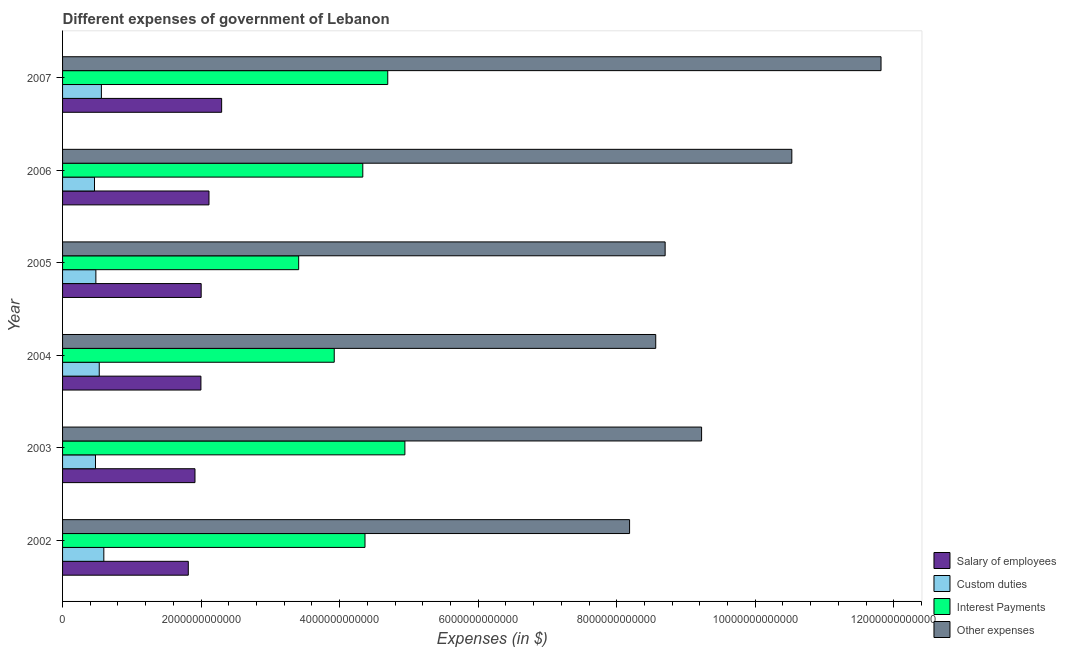How many different coloured bars are there?
Offer a terse response. 4. How many groups of bars are there?
Keep it short and to the point. 6. Are the number of bars on each tick of the Y-axis equal?
Your answer should be very brief. Yes. What is the amount spent on interest payments in 2006?
Your answer should be compact. 4.33e+12. Across all years, what is the maximum amount spent on salary of employees?
Make the answer very short. 2.30e+12. Across all years, what is the minimum amount spent on custom duties?
Your response must be concise. 4.61e+11. In which year was the amount spent on salary of employees maximum?
Keep it short and to the point. 2007. In which year was the amount spent on other expenses minimum?
Provide a succinct answer. 2002. What is the total amount spent on other expenses in the graph?
Provide a short and direct response. 5.70e+13. What is the difference between the amount spent on custom duties in 2002 and that in 2007?
Offer a very short reply. 3.51e+1. What is the difference between the amount spent on custom duties in 2004 and the amount spent on salary of employees in 2006?
Your answer should be very brief. -1.58e+12. What is the average amount spent on salary of employees per year?
Keep it short and to the point. 2.02e+12. In the year 2007, what is the difference between the amount spent on salary of employees and amount spent on interest payments?
Make the answer very short. -2.40e+12. What is the ratio of the amount spent on interest payments in 2004 to that in 2007?
Provide a succinct answer. 0.83. Is the difference between the amount spent on other expenses in 2003 and 2004 greater than the difference between the amount spent on custom duties in 2003 and 2004?
Your answer should be compact. Yes. What is the difference between the highest and the second highest amount spent on interest payments?
Make the answer very short. 2.47e+11. What is the difference between the highest and the lowest amount spent on custom duties?
Offer a terse response. 1.34e+11. In how many years, is the amount spent on interest payments greater than the average amount spent on interest payments taken over all years?
Your response must be concise. 4. Is the sum of the amount spent on salary of employees in 2003 and 2005 greater than the maximum amount spent on interest payments across all years?
Your answer should be compact. No. What does the 4th bar from the top in 2002 represents?
Provide a short and direct response. Salary of employees. What does the 3rd bar from the bottom in 2004 represents?
Offer a terse response. Interest Payments. Is it the case that in every year, the sum of the amount spent on salary of employees and amount spent on custom duties is greater than the amount spent on interest payments?
Keep it short and to the point. No. How many bars are there?
Your response must be concise. 24. How many years are there in the graph?
Keep it short and to the point. 6. What is the difference between two consecutive major ticks on the X-axis?
Provide a short and direct response. 2.00e+12. Are the values on the major ticks of X-axis written in scientific E-notation?
Your answer should be very brief. No. Does the graph contain any zero values?
Give a very brief answer. No. Does the graph contain grids?
Ensure brevity in your answer.  No. Where does the legend appear in the graph?
Your response must be concise. Bottom right. How are the legend labels stacked?
Keep it short and to the point. Vertical. What is the title of the graph?
Provide a succinct answer. Different expenses of government of Lebanon. What is the label or title of the X-axis?
Give a very brief answer. Expenses (in $). What is the label or title of the Y-axis?
Provide a short and direct response. Year. What is the Expenses (in $) of Salary of employees in 2002?
Your response must be concise. 1.82e+12. What is the Expenses (in $) of Custom duties in 2002?
Offer a terse response. 5.96e+11. What is the Expenses (in $) of Interest Payments in 2002?
Make the answer very short. 4.37e+12. What is the Expenses (in $) of Other expenses in 2002?
Provide a short and direct response. 8.19e+12. What is the Expenses (in $) of Salary of employees in 2003?
Give a very brief answer. 1.91e+12. What is the Expenses (in $) of Custom duties in 2003?
Give a very brief answer. 4.75e+11. What is the Expenses (in $) of Interest Payments in 2003?
Your response must be concise. 4.94e+12. What is the Expenses (in $) of Other expenses in 2003?
Give a very brief answer. 9.23e+12. What is the Expenses (in $) in Salary of employees in 2004?
Ensure brevity in your answer.  2.00e+12. What is the Expenses (in $) of Custom duties in 2004?
Offer a very short reply. 5.30e+11. What is the Expenses (in $) in Interest Payments in 2004?
Provide a short and direct response. 3.92e+12. What is the Expenses (in $) of Other expenses in 2004?
Your response must be concise. 8.56e+12. What is the Expenses (in $) of Salary of employees in 2005?
Offer a very short reply. 2.00e+12. What is the Expenses (in $) in Custom duties in 2005?
Provide a short and direct response. 4.81e+11. What is the Expenses (in $) in Interest Payments in 2005?
Ensure brevity in your answer.  3.41e+12. What is the Expenses (in $) of Other expenses in 2005?
Offer a terse response. 8.70e+12. What is the Expenses (in $) of Salary of employees in 2006?
Provide a succinct answer. 2.11e+12. What is the Expenses (in $) of Custom duties in 2006?
Offer a terse response. 4.61e+11. What is the Expenses (in $) of Interest Payments in 2006?
Keep it short and to the point. 4.33e+12. What is the Expenses (in $) in Other expenses in 2006?
Your answer should be very brief. 1.05e+13. What is the Expenses (in $) in Salary of employees in 2007?
Your answer should be compact. 2.30e+12. What is the Expenses (in $) of Custom duties in 2007?
Give a very brief answer. 5.61e+11. What is the Expenses (in $) in Interest Payments in 2007?
Your answer should be very brief. 4.69e+12. What is the Expenses (in $) in Other expenses in 2007?
Give a very brief answer. 1.18e+13. Across all years, what is the maximum Expenses (in $) in Salary of employees?
Ensure brevity in your answer.  2.30e+12. Across all years, what is the maximum Expenses (in $) of Custom duties?
Provide a succinct answer. 5.96e+11. Across all years, what is the maximum Expenses (in $) of Interest Payments?
Provide a succinct answer. 4.94e+12. Across all years, what is the maximum Expenses (in $) of Other expenses?
Keep it short and to the point. 1.18e+13. Across all years, what is the minimum Expenses (in $) of Salary of employees?
Your answer should be compact. 1.82e+12. Across all years, what is the minimum Expenses (in $) of Custom duties?
Your answer should be compact. 4.61e+11. Across all years, what is the minimum Expenses (in $) in Interest Payments?
Your response must be concise. 3.41e+12. Across all years, what is the minimum Expenses (in $) in Other expenses?
Offer a very short reply. 8.19e+12. What is the total Expenses (in $) in Salary of employees in the graph?
Offer a terse response. 1.21e+13. What is the total Expenses (in $) in Custom duties in the graph?
Keep it short and to the point. 3.10e+12. What is the total Expenses (in $) of Interest Payments in the graph?
Offer a terse response. 2.57e+13. What is the total Expenses (in $) of Other expenses in the graph?
Give a very brief answer. 5.70e+13. What is the difference between the Expenses (in $) in Salary of employees in 2002 and that in 2003?
Give a very brief answer. -9.67e+1. What is the difference between the Expenses (in $) in Custom duties in 2002 and that in 2003?
Your answer should be very brief. 1.20e+11. What is the difference between the Expenses (in $) of Interest Payments in 2002 and that in 2003?
Your answer should be compact. -5.76e+11. What is the difference between the Expenses (in $) in Other expenses in 2002 and that in 2003?
Provide a succinct answer. -1.04e+12. What is the difference between the Expenses (in $) in Salary of employees in 2002 and that in 2004?
Your answer should be compact. -1.82e+11. What is the difference between the Expenses (in $) of Custom duties in 2002 and that in 2004?
Make the answer very short. 6.60e+1. What is the difference between the Expenses (in $) of Interest Payments in 2002 and that in 2004?
Offer a terse response. 4.44e+11. What is the difference between the Expenses (in $) in Other expenses in 2002 and that in 2004?
Offer a very short reply. -3.78e+11. What is the difference between the Expenses (in $) of Salary of employees in 2002 and that in 2005?
Provide a short and direct response. -1.86e+11. What is the difference between the Expenses (in $) of Custom duties in 2002 and that in 2005?
Your response must be concise. 1.15e+11. What is the difference between the Expenses (in $) in Interest Payments in 2002 and that in 2005?
Keep it short and to the point. 9.57e+11. What is the difference between the Expenses (in $) in Other expenses in 2002 and that in 2005?
Your response must be concise. -5.14e+11. What is the difference between the Expenses (in $) in Salary of employees in 2002 and that in 2006?
Provide a succinct answer. -2.99e+11. What is the difference between the Expenses (in $) in Custom duties in 2002 and that in 2006?
Keep it short and to the point. 1.34e+11. What is the difference between the Expenses (in $) in Interest Payments in 2002 and that in 2006?
Offer a terse response. 3.16e+1. What is the difference between the Expenses (in $) of Other expenses in 2002 and that in 2006?
Your answer should be compact. -2.34e+12. What is the difference between the Expenses (in $) of Salary of employees in 2002 and that in 2007?
Offer a very short reply. -4.81e+11. What is the difference between the Expenses (in $) of Custom duties in 2002 and that in 2007?
Provide a succinct answer. 3.51e+1. What is the difference between the Expenses (in $) of Interest Payments in 2002 and that in 2007?
Provide a short and direct response. -3.28e+11. What is the difference between the Expenses (in $) of Other expenses in 2002 and that in 2007?
Offer a very short reply. -3.63e+12. What is the difference between the Expenses (in $) of Salary of employees in 2003 and that in 2004?
Offer a very short reply. -8.57e+1. What is the difference between the Expenses (in $) of Custom duties in 2003 and that in 2004?
Ensure brevity in your answer.  -5.42e+1. What is the difference between the Expenses (in $) in Interest Payments in 2003 and that in 2004?
Give a very brief answer. 1.02e+12. What is the difference between the Expenses (in $) in Other expenses in 2003 and that in 2004?
Make the answer very short. 6.62e+11. What is the difference between the Expenses (in $) of Salary of employees in 2003 and that in 2005?
Keep it short and to the point. -8.92e+1. What is the difference between the Expenses (in $) of Custom duties in 2003 and that in 2005?
Make the answer very short. -5.57e+09. What is the difference between the Expenses (in $) in Interest Payments in 2003 and that in 2005?
Your response must be concise. 1.53e+12. What is the difference between the Expenses (in $) of Other expenses in 2003 and that in 2005?
Your response must be concise. 5.26e+11. What is the difference between the Expenses (in $) in Salary of employees in 2003 and that in 2006?
Provide a short and direct response. -2.02e+11. What is the difference between the Expenses (in $) of Custom duties in 2003 and that in 2006?
Your answer should be compact. 1.43e+1. What is the difference between the Expenses (in $) in Interest Payments in 2003 and that in 2006?
Your answer should be very brief. 6.08e+11. What is the difference between the Expenses (in $) of Other expenses in 2003 and that in 2006?
Provide a short and direct response. -1.30e+12. What is the difference between the Expenses (in $) of Salary of employees in 2003 and that in 2007?
Your answer should be very brief. -3.85e+11. What is the difference between the Expenses (in $) of Custom duties in 2003 and that in 2007?
Offer a terse response. -8.51e+1. What is the difference between the Expenses (in $) of Interest Payments in 2003 and that in 2007?
Ensure brevity in your answer.  2.47e+11. What is the difference between the Expenses (in $) in Other expenses in 2003 and that in 2007?
Provide a succinct answer. -2.59e+12. What is the difference between the Expenses (in $) in Salary of employees in 2004 and that in 2005?
Give a very brief answer. -3.43e+09. What is the difference between the Expenses (in $) in Custom duties in 2004 and that in 2005?
Make the answer very short. 4.86e+1. What is the difference between the Expenses (in $) of Interest Payments in 2004 and that in 2005?
Offer a terse response. 5.13e+11. What is the difference between the Expenses (in $) in Other expenses in 2004 and that in 2005?
Ensure brevity in your answer.  -1.36e+11. What is the difference between the Expenses (in $) of Salary of employees in 2004 and that in 2006?
Provide a short and direct response. -1.16e+11. What is the difference between the Expenses (in $) in Custom duties in 2004 and that in 2006?
Your answer should be compact. 6.85e+1. What is the difference between the Expenses (in $) of Interest Payments in 2004 and that in 2006?
Give a very brief answer. -4.12e+11. What is the difference between the Expenses (in $) in Other expenses in 2004 and that in 2006?
Provide a succinct answer. -1.96e+12. What is the difference between the Expenses (in $) of Salary of employees in 2004 and that in 2007?
Provide a succinct answer. -2.99e+11. What is the difference between the Expenses (in $) in Custom duties in 2004 and that in 2007?
Make the answer very short. -3.09e+1. What is the difference between the Expenses (in $) in Interest Payments in 2004 and that in 2007?
Make the answer very short. -7.72e+11. What is the difference between the Expenses (in $) of Other expenses in 2004 and that in 2007?
Ensure brevity in your answer.  -3.25e+12. What is the difference between the Expenses (in $) in Salary of employees in 2005 and that in 2006?
Keep it short and to the point. -1.13e+11. What is the difference between the Expenses (in $) in Custom duties in 2005 and that in 2006?
Provide a short and direct response. 1.98e+1. What is the difference between the Expenses (in $) of Interest Payments in 2005 and that in 2006?
Your answer should be compact. -9.26e+11. What is the difference between the Expenses (in $) of Other expenses in 2005 and that in 2006?
Your response must be concise. -1.83e+12. What is the difference between the Expenses (in $) of Salary of employees in 2005 and that in 2007?
Provide a succinct answer. -2.96e+11. What is the difference between the Expenses (in $) in Custom duties in 2005 and that in 2007?
Give a very brief answer. -7.96e+1. What is the difference between the Expenses (in $) of Interest Payments in 2005 and that in 2007?
Your response must be concise. -1.29e+12. What is the difference between the Expenses (in $) of Other expenses in 2005 and that in 2007?
Keep it short and to the point. -3.12e+12. What is the difference between the Expenses (in $) of Salary of employees in 2006 and that in 2007?
Offer a very short reply. -1.83e+11. What is the difference between the Expenses (in $) in Custom duties in 2006 and that in 2007?
Your answer should be compact. -9.94e+1. What is the difference between the Expenses (in $) in Interest Payments in 2006 and that in 2007?
Keep it short and to the point. -3.60e+11. What is the difference between the Expenses (in $) in Other expenses in 2006 and that in 2007?
Your answer should be very brief. -1.29e+12. What is the difference between the Expenses (in $) in Salary of employees in 2002 and the Expenses (in $) in Custom duties in 2003?
Give a very brief answer. 1.34e+12. What is the difference between the Expenses (in $) of Salary of employees in 2002 and the Expenses (in $) of Interest Payments in 2003?
Provide a succinct answer. -3.13e+12. What is the difference between the Expenses (in $) of Salary of employees in 2002 and the Expenses (in $) of Other expenses in 2003?
Your answer should be very brief. -7.41e+12. What is the difference between the Expenses (in $) in Custom duties in 2002 and the Expenses (in $) in Interest Payments in 2003?
Your response must be concise. -4.35e+12. What is the difference between the Expenses (in $) of Custom duties in 2002 and the Expenses (in $) of Other expenses in 2003?
Your response must be concise. -8.63e+12. What is the difference between the Expenses (in $) in Interest Payments in 2002 and the Expenses (in $) in Other expenses in 2003?
Give a very brief answer. -4.86e+12. What is the difference between the Expenses (in $) of Salary of employees in 2002 and the Expenses (in $) of Custom duties in 2004?
Provide a short and direct response. 1.29e+12. What is the difference between the Expenses (in $) in Salary of employees in 2002 and the Expenses (in $) in Interest Payments in 2004?
Ensure brevity in your answer.  -2.11e+12. What is the difference between the Expenses (in $) of Salary of employees in 2002 and the Expenses (in $) of Other expenses in 2004?
Offer a terse response. -6.75e+12. What is the difference between the Expenses (in $) in Custom duties in 2002 and the Expenses (in $) in Interest Payments in 2004?
Offer a very short reply. -3.33e+12. What is the difference between the Expenses (in $) of Custom duties in 2002 and the Expenses (in $) of Other expenses in 2004?
Ensure brevity in your answer.  -7.97e+12. What is the difference between the Expenses (in $) in Interest Payments in 2002 and the Expenses (in $) in Other expenses in 2004?
Offer a very short reply. -4.20e+12. What is the difference between the Expenses (in $) of Salary of employees in 2002 and the Expenses (in $) of Custom duties in 2005?
Keep it short and to the point. 1.33e+12. What is the difference between the Expenses (in $) in Salary of employees in 2002 and the Expenses (in $) in Interest Payments in 2005?
Your response must be concise. -1.59e+12. What is the difference between the Expenses (in $) in Salary of employees in 2002 and the Expenses (in $) in Other expenses in 2005?
Provide a short and direct response. -6.88e+12. What is the difference between the Expenses (in $) of Custom duties in 2002 and the Expenses (in $) of Interest Payments in 2005?
Provide a succinct answer. -2.81e+12. What is the difference between the Expenses (in $) in Custom duties in 2002 and the Expenses (in $) in Other expenses in 2005?
Make the answer very short. -8.10e+12. What is the difference between the Expenses (in $) of Interest Payments in 2002 and the Expenses (in $) of Other expenses in 2005?
Your answer should be very brief. -4.33e+12. What is the difference between the Expenses (in $) in Salary of employees in 2002 and the Expenses (in $) in Custom duties in 2006?
Your response must be concise. 1.35e+12. What is the difference between the Expenses (in $) in Salary of employees in 2002 and the Expenses (in $) in Interest Payments in 2006?
Provide a short and direct response. -2.52e+12. What is the difference between the Expenses (in $) of Salary of employees in 2002 and the Expenses (in $) of Other expenses in 2006?
Ensure brevity in your answer.  -8.71e+12. What is the difference between the Expenses (in $) of Custom duties in 2002 and the Expenses (in $) of Interest Payments in 2006?
Make the answer very short. -3.74e+12. What is the difference between the Expenses (in $) of Custom duties in 2002 and the Expenses (in $) of Other expenses in 2006?
Provide a short and direct response. -9.93e+12. What is the difference between the Expenses (in $) in Interest Payments in 2002 and the Expenses (in $) in Other expenses in 2006?
Offer a terse response. -6.16e+12. What is the difference between the Expenses (in $) of Salary of employees in 2002 and the Expenses (in $) of Custom duties in 2007?
Provide a short and direct response. 1.25e+12. What is the difference between the Expenses (in $) of Salary of employees in 2002 and the Expenses (in $) of Interest Payments in 2007?
Your answer should be compact. -2.88e+12. What is the difference between the Expenses (in $) of Salary of employees in 2002 and the Expenses (in $) of Other expenses in 2007?
Your answer should be very brief. -1.00e+13. What is the difference between the Expenses (in $) in Custom duties in 2002 and the Expenses (in $) in Interest Payments in 2007?
Ensure brevity in your answer.  -4.10e+12. What is the difference between the Expenses (in $) in Custom duties in 2002 and the Expenses (in $) in Other expenses in 2007?
Ensure brevity in your answer.  -1.12e+13. What is the difference between the Expenses (in $) of Interest Payments in 2002 and the Expenses (in $) of Other expenses in 2007?
Ensure brevity in your answer.  -7.45e+12. What is the difference between the Expenses (in $) of Salary of employees in 2003 and the Expenses (in $) of Custom duties in 2004?
Give a very brief answer. 1.38e+12. What is the difference between the Expenses (in $) in Salary of employees in 2003 and the Expenses (in $) in Interest Payments in 2004?
Keep it short and to the point. -2.01e+12. What is the difference between the Expenses (in $) in Salary of employees in 2003 and the Expenses (in $) in Other expenses in 2004?
Ensure brevity in your answer.  -6.65e+12. What is the difference between the Expenses (in $) in Custom duties in 2003 and the Expenses (in $) in Interest Payments in 2004?
Keep it short and to the point. -3.45e+12. What is the difference between the Expenses (in $) of Custom duties in 2003 and the Expenses (in $) of Other expenses in 2004?
Your answer should be very brief. -8.09e+12. What is the difference between the Expenses (in $) of Interest Payments in 2003 and the Expenses (in $) of Other expenses in 2004?
Your answer should be compact. -3.62e+12. What is the difference between the Expenses (in $) in Salary of employees in 2003 and the Expenses (in $) in Custom duties in 2005?
Keep it short and to the point. 1.43e+12. What is the difference between the Expenses (in $) in Salary of employees in 2003 and the Expenses (in $) in Interest Payments in 2005?
Ensure brevity in your answer.  -1.50e+12. What is the difference between the Expenses (in $) in Salary of employees in 2003 and the Expenses (in $) in Other expenses in 2005?
Ensure brevity in your answer.  -6.79e+12. What is the difference between the Expenses (in $) in Custom duties in 2003 and the Expenses (in $) in Interest Payments in 2005?
Provide a short and direct response. -2.93e+12. What is the difference between the Expenses (in $) in Custom duties in 2003 and the Expenses (in $) in Other expenses in 2005?
Offer a very short reply. -8.22e+12. What is the difference between the Expenses (in $) in Interest Payments in 2003 and the Expenses (in $) in Other expenses in 2005?
Provide a short and direct response. -3.76e+12. What is the difference between the Expenses (in $) in Salary of employees in 2003 and the Expenses (in $) in Custom duties in 2006?
Give a very brief answer. 1.45e+12. What is the difference between the Expenses (in $) in Salary of employees in 2003 and the Expenses (in $) in Interest Payments in 2006?
Your response must be concise. -2.42e+12. What is the difference between the Expenses (in $) of Salary of employees in 2003 and the Expenses (in $) of Other expenses in 2006?
Your answer should be compact. -8.62e+12. What is the difference between the Expenses (in $) in Custom duties in 2003 and the Expenses (in $) in Interest Payments in 2006?
Give a very brief answer. -3.86e+12. What is the difference between the Expenses (in $) of Custom duties in 2003 and the Expenses (in $) of Other expenses in 2006?
Offer a very short reply. -1.01e+13. What is the difference between the Expenses (in $) of Interest Payments in 2003 and the Expenses (in $) of Other expenses in 2006?
Provide a succinct answer. -5.59e+12. What is the difference between the Expenses (in $) in Salary of employees in 2003 and the Expenses (in $) in Custom duties in 2007?
Ensure brevity in your answer.  1.35e+12. What is the difference between the Expenses (in $) of Salary of employees in 2003 and the Expenses (in $) of Interest Payments in 2007?
Offer a very short reply. -2.78e+12. What is the difference between the Expenses (in $) in Salary of employees in 2003 and the Expenses (in $) in Other expenses in 2007?
Keep it short and to the point. -9.90e+12. What is the difference between the Expenses (in $) of Custom duties in 2003 and the Expenses (in $) of Interest Payments in 2007?
Give a very brief answer. -4.22e+12. What is the difference between the Expenses (in $) in Custom duties in 2003 and the Expenses (in $) in Other expenses in 2007?
Your answer should be very brief. -1.13e+13. What is the difference between the Expenses (in $) of Interest Payments in 2003 and the Expenses (in $) of Other expenses in 2007?
Offer a terse response. -6.87e+12. What is the difference between the Expenses (in $) of Salary of employees in 2004 and the Expenses (in $) of Custom duties in 2005?
Provide a short and direct response. 1.52e+12. What is the difference between the Expenses (in $) of Salary of employees in 2004 and the Expenses (in $) of Interest Payments in 2005?
Provide a succinct answer. -1.41e+12. What is the difference between the Expenses (in $) of Salary of employees in 2004 and the Expenses (in $) of Other expenses in 2005?
Ensure brevity in your answer.  -6.70e+12. What is the difference between the Expenses (in $) of Custom duties in 2004 and the Expenses (in $) of Interest Payments in 2005?
Make the answer very short. -2.88e+12. What is the difference between the Expenses (in $) in Custom duties in 2004 and the Expenses (in $) in Other expenses in 2005?
Your answer should be compact. -8.17e+12. What is the difference between the Expenses (in $) of Interest Payments in 2004 and the Expenses (in $) of Other expenses in 2005?
Make the answer very short. -4.78e+12. What is the difference between the Expenses (in $) in Salary of employees in 2004 and the Expenses (in $) in Custom duties in 2006?
Make the answer very short. 1.54e+12. What is the difference between the Expenses (in $) of Salary of employees in 2004 and the Expenses (in $) of Interest Payments in 2006?
Keep it short and to the point. -2.34e+12. What is the difference between the Expenses (in $) of Salary of employees in 2004 and the Expenses (in $) of Other expenses in 2006?
Your response must be concise. -8.53e+12. What is the difference between the Expenses (in $) of Custom duties in 2004 and the Expenses (in $) of Interest Payments in 2006?
Offer a very short reply. -3.80e+12. What is the difference between the Expenses (in $) of Custom duties in 2004 and the Expenses (in $) of Other expenses in 2006?
Offer a very short reply. -1.00e+13. What is the difference between the Expenses (in $) in Interest Payments in 2004 and the Expenses (in $) in Other expenses in 2006?
Provide a short and direct response. -6.61e+12. What is the difference between the Expenses (in $) of Salary of employees in 2004 and the Expenses (in $) of Custom duties in 2007?
Provide a short and direct response. 1.44e+12. What is the difference between the Expenses (in $) in Salary of employees in 2004 and the Expenses (in $) in Interest Payments in 2007?
Your answer should be very brief. -2.70e+12. What is the difference between the Expenses (in $) of Salary of employees in 2004 and the Expenses (in $) of Other expenses in 2007?
Keep it short and to the point. -9.82e+12. What is the difference between the Expenses (in $) in Custom duties in 2004 and the Expenses (in $) in Interest Payments in 2007?
Offer a very short reply. -4.16e+12. What is the difference between the Expenses (in $) in Custom duties in 2004 and the Expenses (in $) in Other expenses in 2007?
Give a very brief answer. -1.13e+13. What is the difference between the Expenses (in $) of Interest Payments in 2004 and the Expenses (in $) of Other expenses in 2007?
Give a very brief answer. -7.89e+12. What is the difference between the Expenses (in $) in Salary of employees in 2005 and the Expenses (in $) in Custom duties in 2006?
Provide a succinct answer. 1.54e+12. What is the difference between the Expenses (in $) of Salary of employees in 2005 and the Expenses (in $) of Interest Payments in 2006?
Your answer should be very brief. -2.33e+12. What is the difference between the Expenses (in $) in Salary of employees in 2005 and the Expenses (in $) in Other expenses in 2006?
Give a very brief answer. -8.53e+12. What is the difference between the Expenses (in $) in Custom duties in 2005 and the Expenses (in $) in Interest Payments in 2006?
Your answer should be very brief. -3.85e+12. What is the difference between the Expenses (in $) of Custom duties in 2005 and the Expenses (in $) of Other expenses in 2006?
Give a very brief answer. -1.00e+13. What is the difference between the Expenses (in $) in Interest Payments in 2005 and the Expenses (in $) in Other expenses in 2006?
Your answer should be very brief. -7.12e+12. What is the difference between the Expenses (in $) of Salary of employees in 2005 and the Expenses (in $) of Custom duties in 2007?
Make the answer very short. 1.44e+12. What is the difference between the Expenses (in $) of Salary of employees in 2005 and the Expenses (in $) of Interest Payments in 2007?
Offer a terse response. -2.69e+12. What is the difference between the Expenses (in $) of Salary of employees in 2005 and the Expenses (in $) of Other expenses in 2007?
Make the answer very short. -9.82e+12. What is the difference between the Expenses (in $) in Custom duties in 2005 and the Expenses (in $) in Interest Payments in 2007?
Offer a terse response. -4.21e+12. What is the difference between the Expenses (in $) of Custom duties in 2005 and the Expenses (in $) of Other expenses in 2007?
Give a very brief answer. -1.13e+13. What is the difference between the Expenses (in $) in Interest Payments in 2005 and the Expenses (in $) in Other expenses in 2007?
Offer a very short reply. -8.41e+12. What is the difference between the Expenses (in $) of Salary of employees in 2006 and the Expenses (in $) of Custom duties in 2007?
Give a very brief answer. 1.55e+12. What is the difference between the Expenses (in $) in Salary of employees in 2006 and the Expenses (in $) in Interest Payments in 2007?
Offer a very short reply. -2.58e+12. What is the difference between the Expenses (in $) of Salary of employees in 2006 and the Expenses (in $) of Other expenses in 2007?
Ensure brevity in your answer.  -9.70e+12. What is the difference between the Expenses (in $) in Custom duties in 2006 and the Expenses (in $) in Interest Payments in 2007?
Keep it short and to the point. -4.23e+12. What is the difference between the Expenses (in $) in Custom duties in 2006 and the Expenses (in $) in Other expenses in 2007?
Keep it short and to the point. -1.14e+13. What is the difference between the Expenses (in $) of Interest Payments in 2006 and the Expenses (in $) of Other expenses in 2007?
Offer a very short reply. -7.48e+12. What is the average Expenses (in $) in Salary of employees per year?
Your answer should be compact. 2.02e+12. What is the average Expenses (in $) in Custom duties per year?
Your answer should be compact. 5.17e+11. What is the average Expenses (in $) in Interest Payments per year?
Keep it short and to the point. 4.28e+12. What is the average Expenses (in $) of Other expenses per year?
Provide a succinct answer. 9.50e+12. In the year 2002, what is the difference between the Expenses (in $) of Salary of employees and Expenses (in $) of Custom duties?
Offer a terse response. 1.22e+12. In the year 2002, what is the difference between the Expenses (in $) in Salary of employees and Expenses (in $) in Interest Payments?
Keep it short and to the point. -2.55e+12. In the year 2002, what is the difference between the Expenses (in $) in Salary of employees and Expenses (in $) in Other expenses?
Ensure brevity in your answer.  -6.37e+12. In the year 2002, what is the difference between the Expenses (in $) in Custom duties and Expenses (in $) in Interest Payments?
Your answer should be compact. -3.77e+12. In the year 2002, what is the difference between the Expenses (in $) of Custom duties and Expenses (in $) of Other expenses?
Your answer should be very brief. -7.59e+12. In the year 2002, what is the difference between the Expenses (in $) in Interest Payments and Expenses (in $) in Other expenses?
Give a very brief answer. -3.82e+12. In the year 2003, what is the difference between the Expenses (in $) of Salary of employees and Expenses (in $) of Custom duties?
Keep it short and to the point. 1.44e+12. In the year 2003, what is the difference between the Expenses (in $) in Salary of employees and Expenses (in $) in Interest Payments?
Keep it short and to the point. -3.03e+12. In the year 2003, what is the difference between the Expenses (in $) in Salary of employees and Expenses (in $) in Other expenses?
Make the answer very short. -7.31e+12. In the year 2003, what is the difference between the Expenses (in $) in Custom duties and Expenses (in $) in Interest Payments?
Offer a very short reply. -4.47e+12. In the year 2003, what is the difference between the Expenses (in $) of Custom duties and Expenses (in $) of Other expenses?
Your answer should be very brief. -8.75e+12. In the year 2003, what is the difference between the Expenses (in $) in Interest Payments and Expenses (in $) in Other expenses?
Ensure brevity in your answer.  -4.28e+12. In the year 2004, what is the difference between the Expenses (in $) in Salary of employees and Expenses (in $) in Custom duties?
Keep it short and to the point. 1.47e+12. In the year 2004, what is the difference between the Expenses (in $) in Salary of employees and Expenses (in $) in Interest Payments?
Your answer should be compact. -1.92e+12. In the year 2004, what is the difference between the Expenses (in $) in Salary of employees and Expenses (in $) in Other expenses?
Your response must be concise. -6.57e+12. In the year 2004, what is the difference between the Expenses (in $) of Custom duties and Expenses (in $) of Interest Payments?
Offer a terse response. -3.39e+12. In the year 2004, what is the difference between the Expenses (in $) in Custom duties and Expenses (in $) in Other expenses?
Keep it short and to the point. -8.03e+12. In the year 2004, what is the difference between the Expenses (in $) of Interest Payments and Expenses (in $) of Other expenses?
Provide a succinct answer. -4.64e+12. In the year 2005, what is the difference between the Expenses (in $) of Salary of employees and Expenses (in $) of Custom duties?
Provide a succinct answer. 1.52e+12. In the year 2005, what is the difference between the Expenses (in $) in Salary of employees and Expenses (in $) in Interest Payments?
Offer a very short reply. -1.41e+12. In the year 2005, what is the difference between the Expenses (in $) in Salary of employees and Expenses (in $) in Other expenses?
Your answer should be compact. -6.70e+12. In the year 2005, what is the difference between the Expenses (in $) in Custom duties and Expenses (in $) in Interest Payments?
Keep it short and to the point. -2.93e+12. In the year 2005, what is the difference between the Expenses (in $) of Custom duties and Expenses (in $) of Other expenses?
Provide a succinct answer. -8.22e+12. In the year 2005, what is the difference between the Expenses (in $) in Interest Payments and Expenses (in $) in Other expenses?
Offer a terse response. -5.29e+12. In the year 2006, what is the difference between the Expenses (in $) of Salary of employees and Expenses (in $) of Custom duties?
Ensure brevity in your answer.  1.65e+12. In the year 2006, what is the difference between the Expenses (in $) of Salary of employees and Expenses (in $) of Interest Payments?
Your answer should be compact. -2.22e+12. In the year 2006, what is the difference between the Expenses (in $) in Salary of employees and Expenses (in $) in Other expenses?
Your response must be concise. -8.41e+12. In the year 2006, what is the difference between the Expenses (in $) in Custom duties and Expenses (in $) in Interest Payments?
Keep it short and to the point. -3.87e+12. In the year 2006, what is the difference between the Expenses (in $) in Custom duties and Expenses (in $) in Other expenses?
Offer a terse response. -1.01e+13. In the year 2006, what is the difference between the Expenses (in $) in Interest Payments and Expenses (in $) in Other expenses?
Ensure brevity in your answer.  -6.19e+12. In the year 2007, what is the difference between the Expenses (in $) of Salary of employees and Expenses (in $) of Custom duties?
Give a very brief answer. 1.74e+12. In the year 2007, what is the difference between the Expenses (in $) in Salary of employees and Expenses (in $) in Interest Payments?
Provide a succinct answer. -2.40e+12. In the year 2007, what is the difference between the Expenses (in $) in Salary of employees and Expenses (in $) in Other expenses?
Your answer should be compact. -9.52e+12. In the year 2007, what is the difference between the Expenses (in $) of Custom duties and Expenses (in $) of Interest Payments?
Your answer should be compact. -4.13e+12. In the year 2007, what is the difference between the Expenses (in $) of Custom duties and Expenses (in $) of Other expenses?
Your response must be concise. -1.13e+13. In the year 2007, what is the difference between the Expenses (in $) in Interest Payments and Expenses (in $) in Other expenses?
Make the answer very short. -7.12e+12. What is the ratio of the Expenses (in $) of Salary of employees in 2002 to that in 2003?
Offer a terse response. 0.95. What is the ratio of the Expenses (in $) of Custom duties in 2002 to that in 2003?
Offer a very short reply. 1.25. What is the ratio of the Expenses (in $) of Interest Payments in 2002 to that in 2003?
Give a very brief answer. 0.88. What is the ratio of the Expenses (in $) in Other expenses in 2002 to that in 2003?
Provide a short and direct response. 0.89. What is the ratio of the Expenses (in $) in Salary of employees in 2002 to that in 2004?
Your answer should be very brief. 0.91. What is the ratio of the Expenses (in $) of Custom duties in 2002 to that in 2004?
Your answer should be very brief. 1.12. What is the ratio of the Expenses (in $) of Interest Payments in 2002 to that in 2004?
Offer a terse response. 1.11. What is the ratio of the Expenses (in $) of Other expenses in 2002 to that in 2004?
Your answer should be very brief. 0.96. What is the ratio of the Expenses (in $) in Salary of employees in 2002 to that in 2005?
Your response must be concise. 0.91. What is the ratio of the Expenses (in $) in Custom duties in 2002 to that in 2005?
Give a very brief answer. 1.24. What is the ratio of the Expenses (in $) in Interest Payments in 2002 to that in 2005?
Offer a terse response. 1.28. What is the ratio of the Expenses (in $) in Other expenses in 2002 to that in 2005?
Your answer should be compact. 0.94. What is the ratio of the Expenses (in $) of Salary of employees in 2002 to that in 2006?
Offer a very short reply. 0.86. What is the ratio of the Expenses (in $) in Custom duties in 2002 to that in 2006?
Offer a very short reply. 1.29. What is the ratio of the Expenses (in $) of Interest Payments in 2002 to that in 2006?
Offer a very short reply. 1.01. What is the ratio of the Expenses (in $) of Other expenses in 2002 to that in 2006?
Your response must be concise. 0.78. What is the ratio of the Expenses (in $) in Salary of employees in 2002 to that in 2007?
Keep it short and to the point. 0.79. What is the ratio of the Expenses (in $) in Custom duties in 2002 to that in 2007?
Make the answer very short. 1.06. What is the ratio of the Expenses (in $) of Other expenses in 2002 to that in 2007?
Your answer should be very brief. 0.69. What is the ratio of the Expenses (in $) in Salary of employees in 2003 to that in 2004?
Provide a short and direct response. 0.96. What is the ratio of the Expenses (in $) of Custom duties in 2003 to that in 2004?
Your answer should be compact. 0.9. What is the ratio of the Expenses (in $) of Interest Payments in 2003 to that in 2004?
Your response must be concise. 1.26. What is the ratio of the Expenses (in $) of Other expenses in 2003 to that in 2004?
Provide a succinct answer. 1.08. What is the ratio of the Expenses (in $) of Salary of employees in 2003 to that in 2005?
Provide a succinct answer. 0.96. What is the ratio of the Expenses (in $) in Custom duties in 2003 to that in 2005?
Offer a terse response. 0.99. What is the ratio of the Expenses (in $) in Interest Payments in 2003 to that in 2005?
Give a very brief answer. 1.45. What is the ratio of the Expenses (in $) of Other expenses in 2003 to that in 2005?
Provide a short and direct response. 1.06. What is the ratio of the Expenses (in $) in Salary of employees in 2003 to that in 2006?
Ensure brevity in your answer.  0.9. What is the ratio of the Expenses (in $) of Custom duties in 2003 to that in 2006?
Your response must be concise. 1.03. What is the ratio of the Expenses (in $) of Interest Payments in 2003 to that in 2006?
Provide a short and direct response. 1.14. What is the ratio of the Expenses (in $) in Other expenses in 2003 to that in 2006?
Give a very brief answer. 0.88. What is the ratio of the Expenses (in $) of Salary of employees in 2003 to that in 2007?
Make the answer very short. 0.83. What is the ratio of the Expenses (in $) of Custom duties in 2003 to that in 2007?
Give a very brief answer. 0.85. What is the ratio of the Expenses (in $) in Interest Payments in 2003 to that in 2007?
Your answer should be very brief. 1.05. What is the ratio of the Expenses (in $) of Other expenses in 2003 to that in 2007?
Offer a very short reply. 0.78. What is the ratio of the Expenses (in $) of Salary of employees in 2004 to that in 2005?
Your answer should be very brief. 1. What is the ratio of the Expenses (in $) in Custom duties in 2004 to that in 2005?
Offer a terse response. 1.1. What is the ratio of the Expenses (in $) in Interest Payments in 2004 to that in 2005?
Give a very brief answer. 1.15. What is the ratio of the Expenses (in $) of Other expenses in 2004 to that in 2005?
Keep it short and to the point. 0.98. What is the ratio of the Expenses (in $) of Salary of employees in 2004 to that in 2006?
Offer a very short reply. 0.94. What is the ratio of the Expenses (in $) of Custom duties in 2004 to that in 2006?
Provide a succinct answer. 1.15. What is the ratio of the Expenses (in $) in Interest Payments in 2004 to that in 2006?
Ensure brevity in your answer.  0.9. What is the ratio of the Expenses (in $) of Other expenses in 2004 to that in 2006?
Provide a short and direct response. 0.81. What is the ratio of the Expenses (in $) of Salary of employees in 2004 to that in 2007?
Your answer should be compact. 0.87. What is the ratio of the Expenses (in $) in Custom duties in 2004 to that in 2007?
Provide a short and direct response. 0.94. What is the ratio of the Expenses (in $) of Interest Payments in 2004 to that in 2007?
Ensure brevity in your answer.  0.84. What is the ratio of the Expenses (in $) in Other expenses in 2004 to that in 2007?
Provide a short and direct response. 0.72. What is the ratio of the Expenses (in $) of Salary of employees in 2005 to that in 2006?
Provide a succinct answer. 0.95. What is the ratio of the Expenses (in $) in Custom duties in 2005 to that in 2006?
Offer a very short reply. 1.04. What is the ratio of the Expenses (in $) of Interest Payments in 2005 to that in 2006?
Offer a terse response. 0.79. What is the ratio of the Expenses (in $) in Other expenses in 2005 to that in 2006?
Give a very brief answer. 0.83. What is the ratio of the Expenses (in $) of Salary of employees in 2005 to that in 2007?
Give a very brief answer. 0.87. What is the ratio of the Expenses (in $) of Custom duties in 2005 to that in 2007?
Your answer should be very brief. 0.86. What is the ratio of the Expenses (in $) in Interest Payments in 2005 to that in 2007?
Your response must be concise. 0.73. What is the ratio of the Expenses (in $) in Other expenses in 2005 to that in 2007?
Provide a short and direct response. 0.74. What is the ratio of the Expenses (in $) in Salary of employees in 2006 to that in 2007?
Your response must be concise. 0.92. What is the ratio of the Expenses (in $) of Custom duties in 2006 to that in 2007?
Your answer should be very brief. 0.82. What is the ratio of the Expenses (in $) in Interest Payments in 2006 to that in 2007?
Offer a terse response. 0.92. What is the ratio of the Expenses (in $) in Other expenses in 2006 to that in 2007?
Make the answer very short. 0.89. What is the difference between the highest and the second highest Expenses (in $) in Salary of employees?
Provide a short and direct response. 1.83e+11. What is the difference between the highest and the second highest Expenses (in $) in Custom duties?
Give a very brief answer. 3.51e+1. What is the difference between the highest and the second highest Expenses (in $) in Interest Payments?
Keep it short and to the point. 2.47e+11. What is the difference between the highest and the second highest Expenses (in $) in Other expenses?
Ensure brevity in your answer.  1.29e+12. What is the difference between the highest and the lowest Expenses (in $) in Salary of employees?
Offer a terse response. 4.81e+11. What is the difference between the highest and the lowest Expenses (in $) in Custom duties?
Your answer should be very brief. 1.34e+11. What is the difference between the highest and the lowest Expenses (in $) in Interest Payments?
Give a very brief answer. 1.53e+12. What is the difference between the highest and the lowest Expenses (in $) of Other expenses?
Keep it short and to the point. 3.63e+12. 